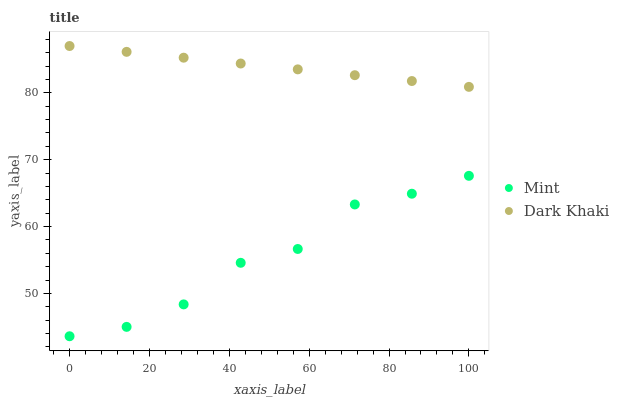Does Mint have the minimum area under the curve?
Answer yes or no. Yes. Does Dark Khaki have the maximum area under the curve?
Answer yes or no. Yes. Does Mint have the maximum area under the curve?
Answer yes or no. No. Is Dark Khaki the smoothest?
Answer yes or no. Yes. Is Mint the roughest?
Answer yes or no. Yes. Is Mint the smoothest?
Answer yes or no. No. Does Mint have the lowest value?
Answer yes or no. Yes. Does Dark Khaki have the highest value?
Answer yes or no. Yes. Does Mint have the highest value?
Answer yes or no. No. Is Mint less than Dark Khaki?
Answer yes or no. Yes. Is Dark Khaki greater than Mint?
Answer yes or no. Yes. Does Mint intersect Dark Khaki?
Answer yes or no. No. 